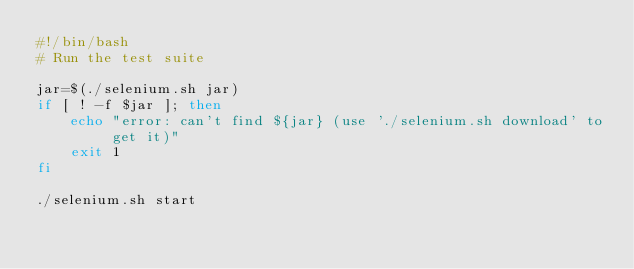Convert code to text. <code><loc_0><loc_0><loc_500><loc_500><_Bash_>#!/bin/bash
# Run the test suite

jar=$(./selenium.sh jar)
if [ ! -f $jar ]; then
	echo "error: can't find ${jar} (use './selenium.sh download' to get it)"
	exit 1
fi

./selenium.sh start</code> 